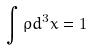Convert formula to latex. <formula><loc_0><loc_0><loc_500><loc_500>\int \rho d ^ { 3 } x = 1</formula> 